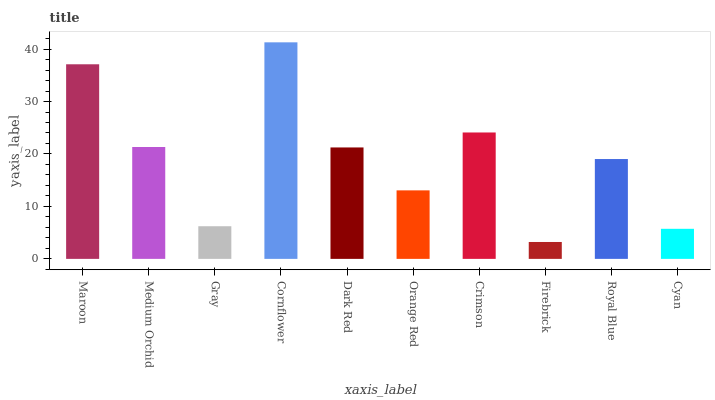Is Firebrick the minimum?
Answer yes or no. Yes. Is Cornflower the maximum?
Answer yes or no. Yes. Is Medium Orchid the minimum?
Answer yes or no. No. Is Medium Orchid the maximum?
Answer yes or no. No. Is Maroon greater than Medium Orchid?
Answer yes or no. Yes. Is Medium Orchid less than Maroon?
Answer yes or no. Yes. Is Medium Orchid greater than Maroon?
Answer yes or no. No. Is Maroon less than Medium Orchid?
Answer yes or no. No. Is Dark Red the high median?
Answer yes or no. Yes. Is Royal Blue the low median?
Answer yes or no. Yes. Is Gray the high median?
Answer yes or no. No. Is Cyan the low median?
Answer yes or no. No. 